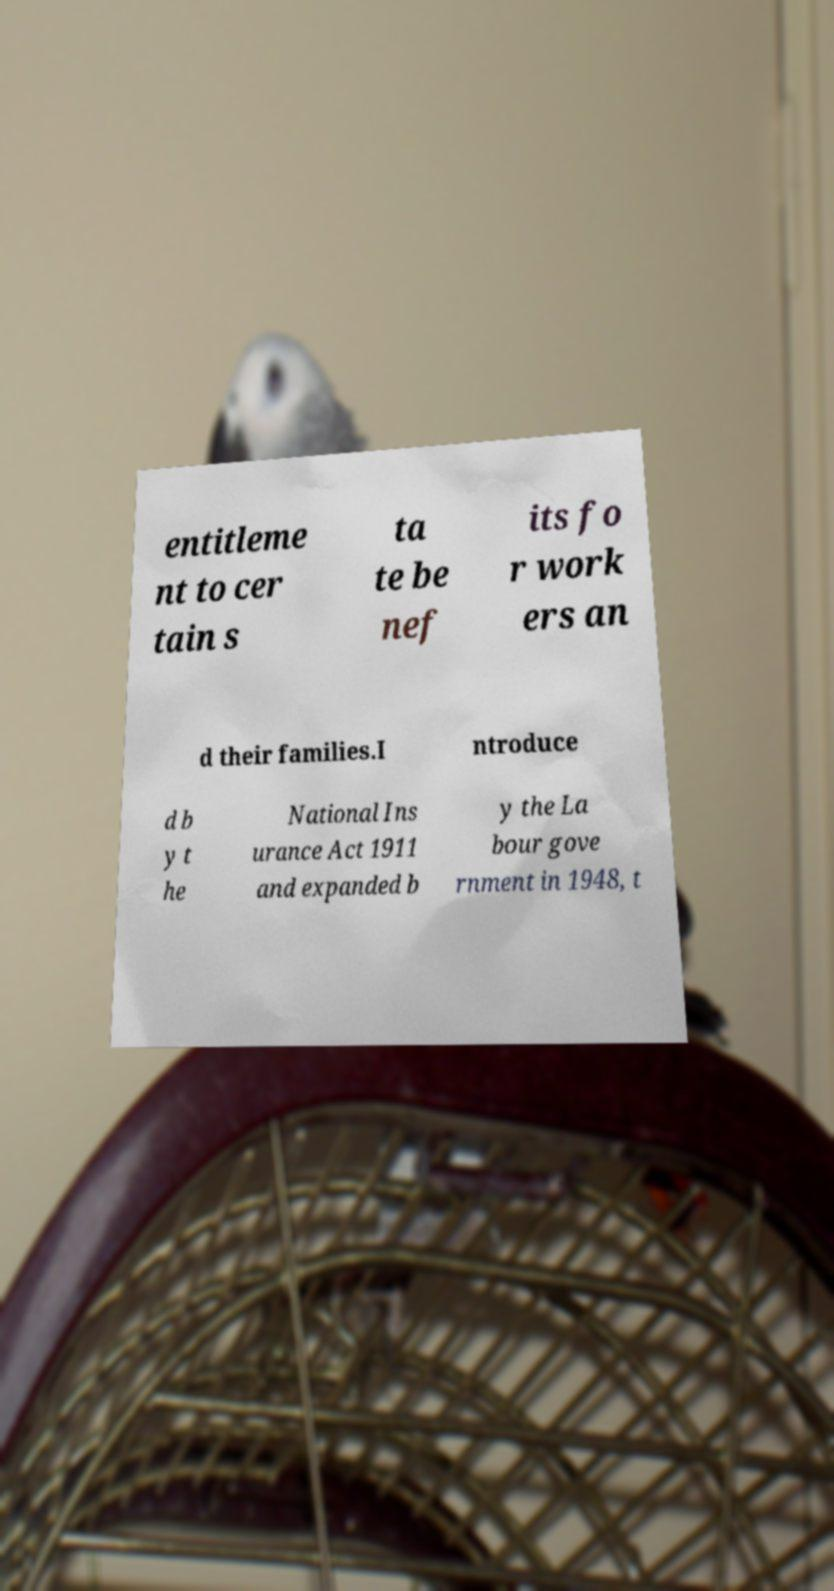There's text embedded in this image that I need extracted. Can you transcribe it verbatim? entitleme nt to cer tain s ta te be nef its fo r work ers an d their families.I ntroduce d b y t he National Ins urance Act 1911 and expanded b y the La bour gove rnment in 1948, t 